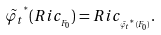Convert formula to latex. <formula><loc_0><loc_0><loc_500><loc_500>\tilde { \varphi _ { t } } ^ { ^ { * } } ( R i c _ { _ { F _ { 0 } } } ) = R i c _ { _ { \tilde { \varphi _ { t } } ^ { ^ { * } } ( F _ { 0 } ) } } .</formula> 